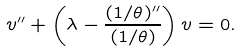Convert formula to latex. <formula><loc_0><loc_0><loc_500><loc_500>v ^ { \prime \prime } + \left ( \lambda - \frac { ( 1 / \theta ) ^ { \prime \prime } } { ( 1 / \theta ) } \right ) v = 0 .</formula> 